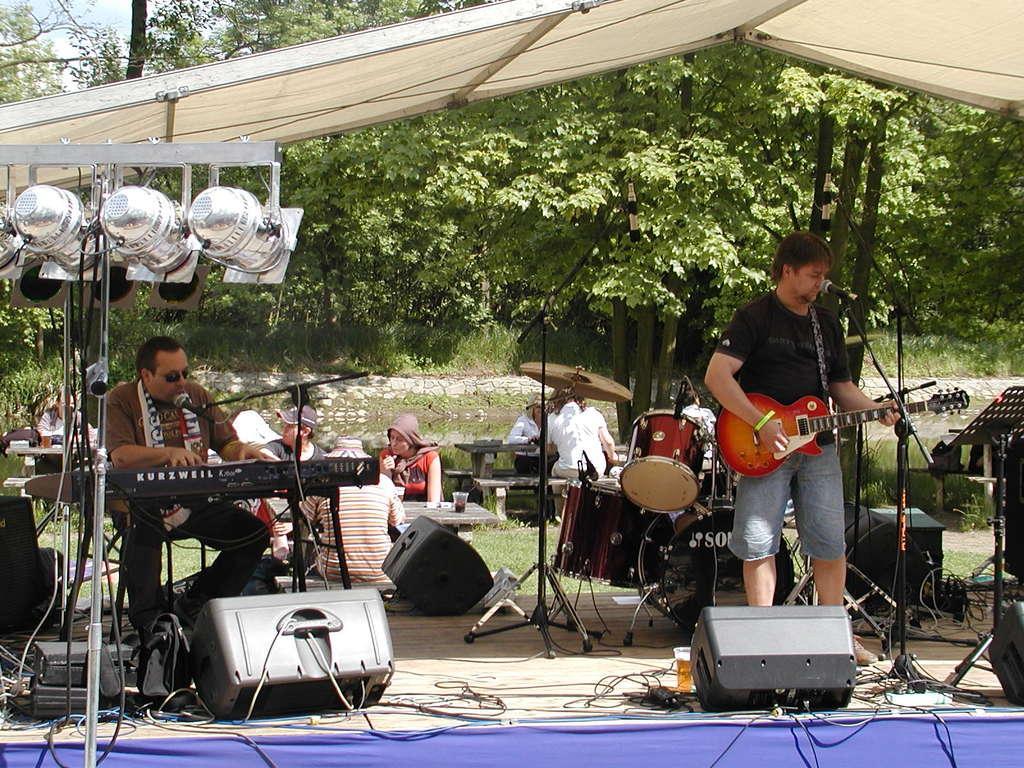Please provide a concise description of this image. In this image, In the right side there is a man standing and he is holding a music instrument which is in red color he is singing in the microphone which is in black color, In the left side there is a man sitting and he is playing a piano which is in black color, There are some lights in white color, In the top there is a white color shade, There are some green color plants and trees. 